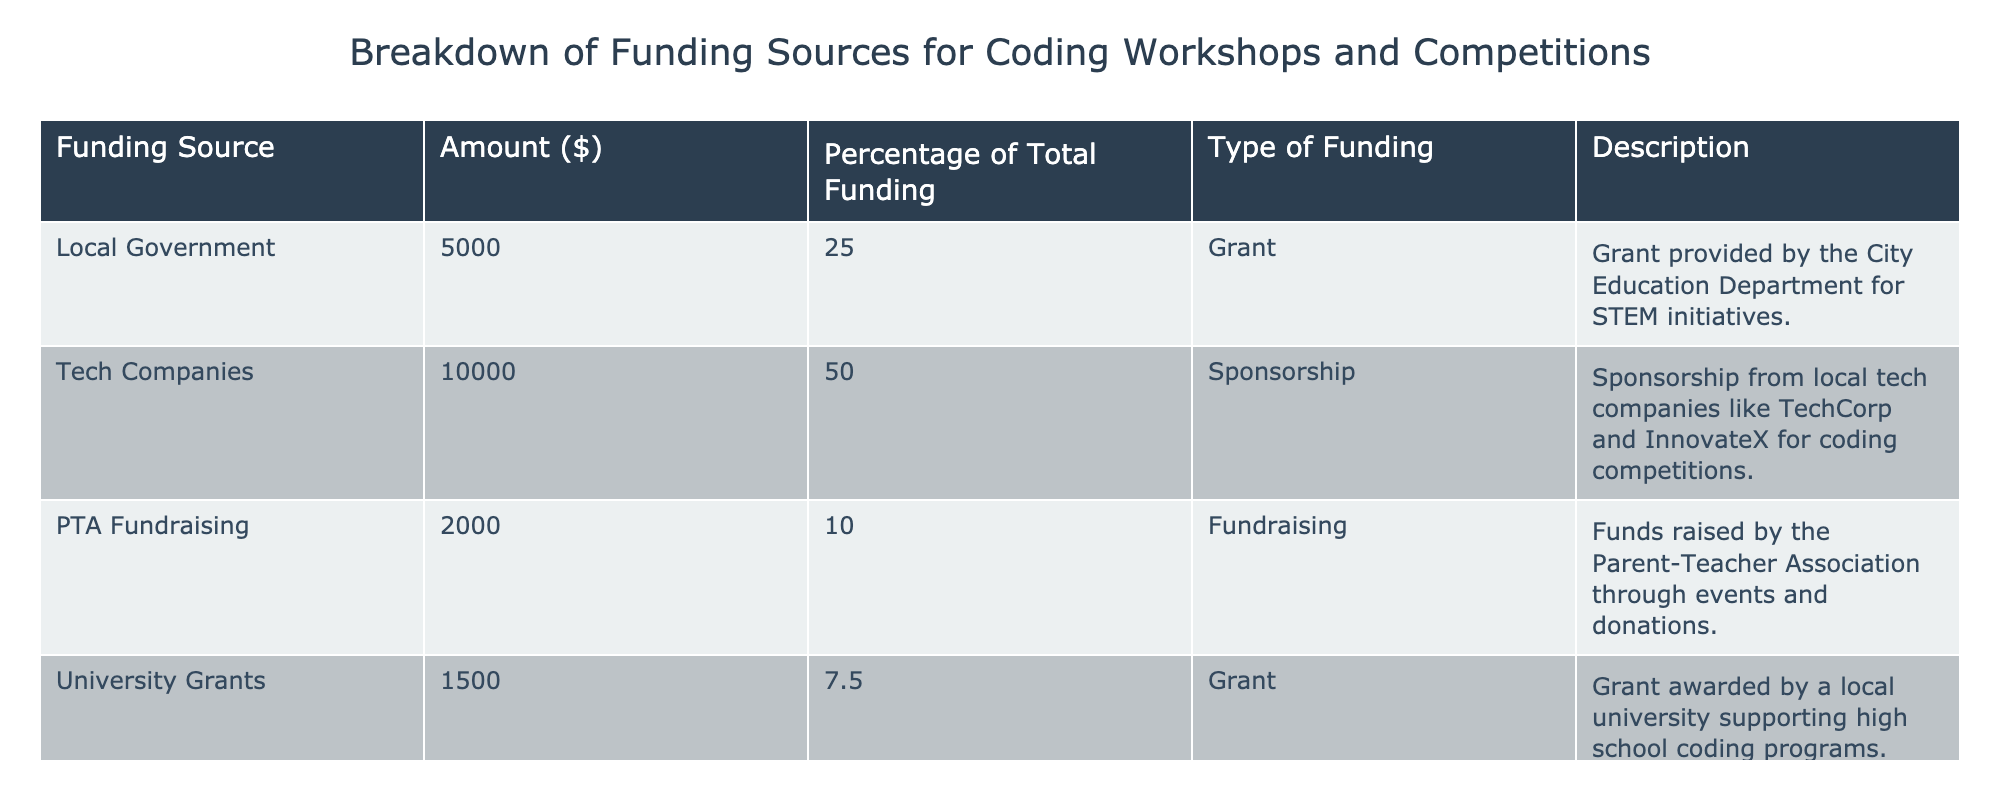What is the total amount of funding from tech companies? The table lists the amount of funding from tech companies as 10000 dollars.
Answer: 10000 What percentage of total funding comes from the local government? From the table, it is indicated that the local government contributes 25% to the total funding.
Answer: 25% Is the funding from community donations equal to the funding from university grants? By checking the table, community donations are listed as 1500 dollars, and university grants are also listed as 1500 dollars. Therefore, they are equal.
Answer: Yes What is the combined amount of funding from PTA fundraising and university grants? The table shows PTA fundraising at 2000 dollars and university grants at 1500 dollars. The combined amount is 2000 + 1500 = 3500 dollars.
Answer: 3500 Which funding source contributes the least to the total funding? According to the table, both university grants and community donations contribute 1500 dollars, which is less than any other funding source.
Answer: University grants and community donations What is the average funding amount from grants? The table lists two grants: one from local government (5000 dollars) and one from the university (1500 dollars). The average can be calculated as (5000 + 1500) / 2 = 3250 dollars.
Answer: 3250 Does tech sponsorship account for more than half of the total funding? The table shows that tech sponsorship amounts to 10000 dollars, which is 50% of total funding. Since half is not more than half, the answer is no.
Answer: No What is the total funding amount from all sources? By adding all funding amounts from the table: 5000 + 10000 + 2000 + 1500 + 1500, the total is 21000 dollars.
Answer: 21000 What funding categories are represented in the data? The table specifies four categories: Grant, Sponsorship, Fundraising, and Donation, with various funding sources falling under these categories.
Answer: Grant, Sponsorship, Fundraising, Donation 